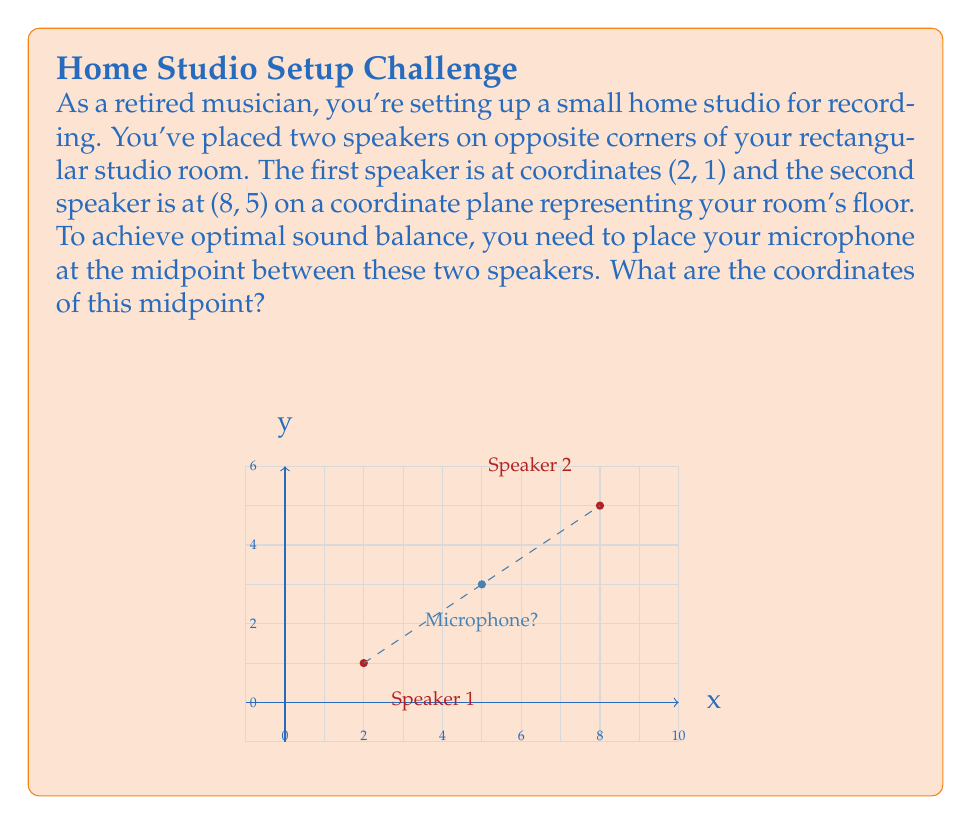Could you help me with this problem? To find the midpoint between two points on a coordinate plane, we use the midpoint formula:

$$ \text{Midpoint} = \left(\frac{x_1 + x_2}{2}, \frac{y_1 + y_2}{2}\right) $$

Where $(x_1, y_1)$ are the coordinates of the first point and $(x_2, y_2)$ are the coordinates of the second point.

Given:
- Speaker 1 is at (2, 1), so $x_1 = 2$ and $y_1 = 1$
- Speaker 2 is at (8, 5), so $x_2 = 8$ and $y_2 = 5$

Let's calculate the x-coordinate of the midpoint:

$$ x_{\text{midpoint}} = \frac{x_1 + x_2}{2} = \frac{2 + 8}{2} = \frac{10}{2} = 5 $$

Now, let's calculate the y-coordinate of the midpoint:

$$ y_{\text{midpoint}} = \frac{y_1 + y_2}{2} = \frac{1 + 5}{2} = \frac{6}{2} = 3 $$

Therefore, the coordinates of the midpoint are (5, 3).
Answer: (5, 3) 